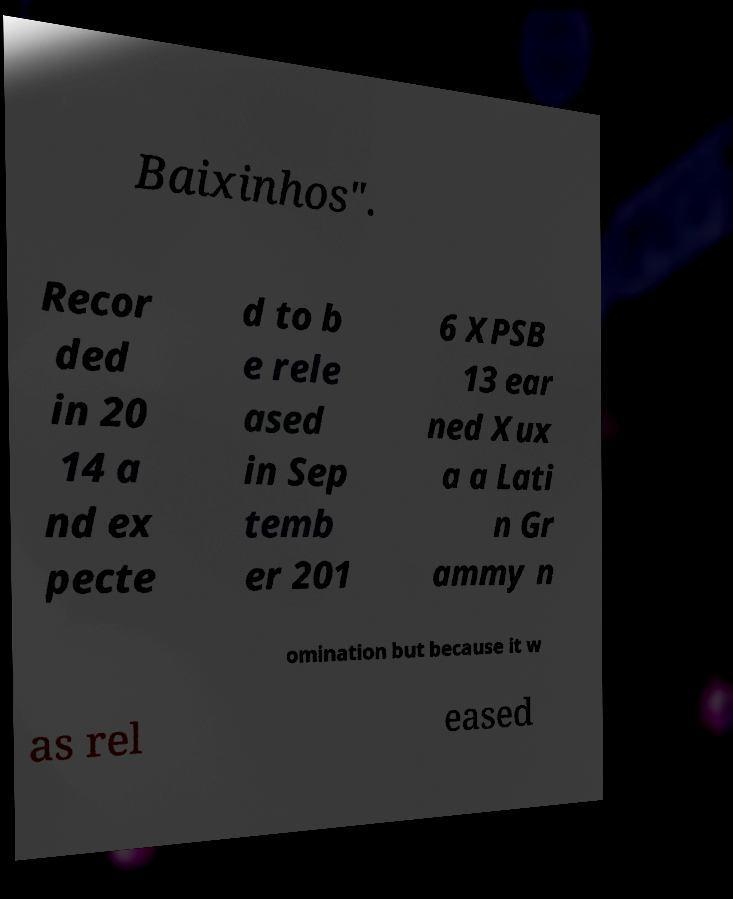Please identify and transcribe the text found in this image. Baixinhos". Recor ded in 20 14 a nd ex pecte d to b e rele ased in Sep temb er 201 6 XPSB 13 ear ned Xux a a Lati n Gr ammy n omination but because it w as rel eased 